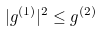<formula> <loc_0><loc_0><loc_500><loc_500>| g ^ { ( 1 ) } | ^ { 2 } \leq g ^ { ( 2 ) }</formula> 